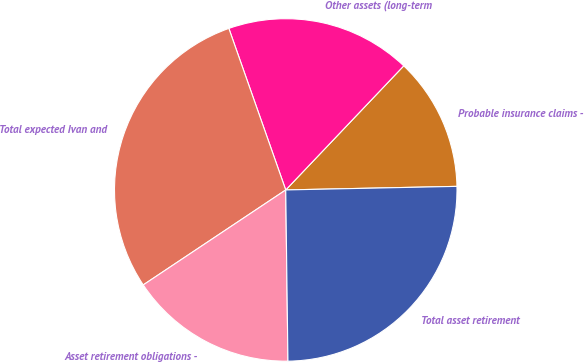Convert chart. <chart><loc_0><loc_0><loc_500><loc_500><pie_chart><fcel>Probable insurance claims -<fcel>Other assets (long-term<fcel>Total expected Ivan and<fcel>Asset retirement obligations -<fcel>Total asset retirement<nl><fcel>12.57%<fcel>17.49%<fcel>28.97%<fcel>15.85%<fcel>25.13%<nl></chart> 